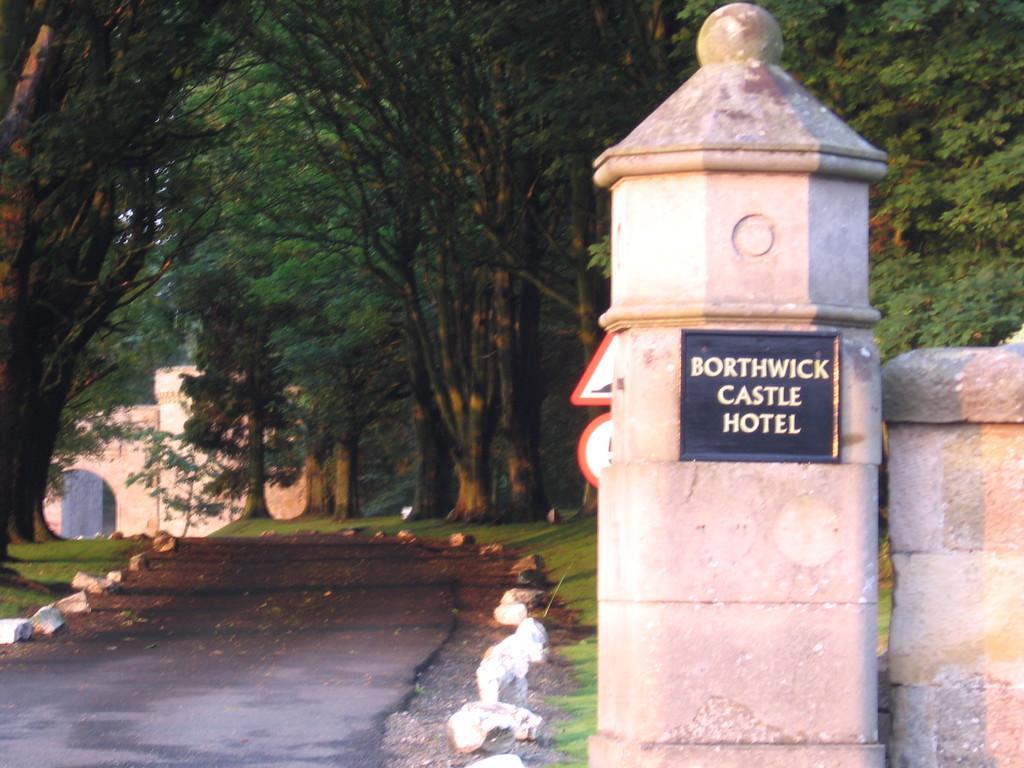Can you describe this image briefly? In this image on the right side there is a wall, on the wall there is one board. On the board there is some text, at the bottom there is a walkway and some rocks. In the background there are houses and group of trees. 